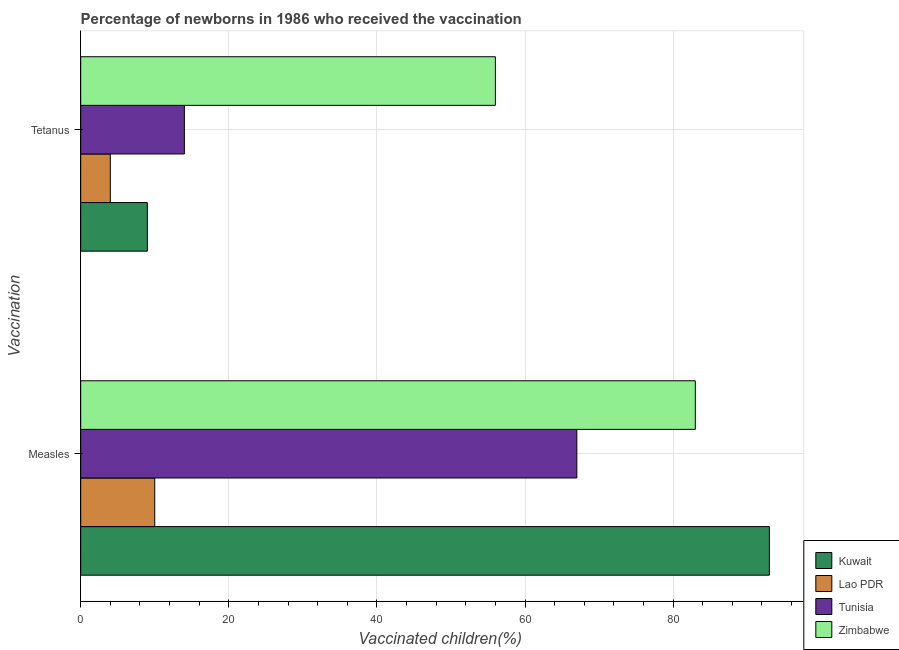How many different coloured bars are there?
Provide a succinct answer. 4. How many groups of bars are there?
Ensure brevity in your answer.  2. How many bars are there on the 2nd tick from the top?
Make the answer very short. 4. What is the label of the 2nd group of bars from the top?
Your answer should be compact. Measles. What is the percentage of newborns who received vaccination for measles in Kuwait?
Offer a terse response. 93. Across all countries, what is the maximum percentage of newborns who received vaccination for measles?
Give a very brief answer. 93. Across all countries, what is the minimum percentage of newborns who received vaccination for tetanus?
Make the answer very short. 4. In which country was the percentage of newborns who received vaccination for measles maximum?
Offer a terse response. Kuwait. In which country was the percentage of newborns who received vaccination for tetanus minimum?
Keep it short and to the point. Lao PDR. What is the total percentage of newborns who received vaccination for measles in the graph?
Provide a short and direct response. 253. What is the difference between the percentage of newborns who received vaccination for tetanus in Kuwait and that in Zimbabwe?
Your response must be concise. -47. What is the difference between the percentage of newborns who received vaccination for tetanus in Lao PDR and the percentage of newborns who received vaccination for measles in Tunisia?
Keep it short and to the point. -63. What is the average percentage of newborns who received vaccination for tetanus per country?
Offer a terse response. 20.75. What is the difference between the percentage of newborns who received vaccination for tetanus and percentage of newborns who received vaccination for measles in Kuwait?
Your answer should be very brief. -84. Is the percentage of newborns who received vaccination for measles in Zimbabwe less than that in Lao PDR?
Your answer should be compact. No. What does the 1st bar from the top in Tetanus represents?
Ensure brevity in your answer.  Zimbabwe. What does the 3rd bar from the bottom in Tetanus represents?
Provide a short and direct response. Tunisia. Are all the bars in the graph horizontal?
Provide a short and direct response. Yes. How many countries are there in the graph?
Make the answer very short. 4. What is the difference between two consecutive major ticks on the X-axis?
Give a very brief answer. 20. Are the values on the major ticks of X-axis written in scientific E-notation?
Ensure brevity in your answer.  No. Where does the legend appear in the graph?
Provide a short and direct response. Bottom right. How many legend labels are there?
Make the answer very short. 4. What is the title of the graph?
Your answer should be compact. Percentage of newborns in 1986 who received the vaccination. Does "South Africa" appear as one of the legend labels in the graph?
Provide a short and direct response. No. What is the label or title of the X-axis?
Keep it short and to the point. Vaccinated children(%)
. What is the label or title of the Y-axis?
Provide a short and direct response. Vaccination. What is the Vaccinated children(%)
 of Kuwait in Measles?
Make the answer very short. 93. What is the Vaccinated children(%)
 in Lao PDR in Measles?
Your answer should be compact. 10. What is the Vaccinated children(%)
 of Tunisia in Measles?
Your response must be concise. 67. What is the Vaccinated children(%)
 of Zimbabwe in Measles?
Ensure brevity in your answer.  83. What is the Vaccinated children(%)
 of Kuwait in Tetanus?
Offer a terse response. 9. What is the Vaccinated children(%)
 of Lao PDR in Tetanus?
Provide a short and direct response. 4. What is the Vaccinated children(%)
 of Tunisia in Tetanus?
Your answer should be compact. 14. Across all Vaccination, what is the maximum Vaccinated children(%)
 of Kuwait?
Your answer should be very brief. 93. Across all Vaccination, what is the maximum Vaccinated children(%)
 in Zimbabwe?
Offer a terse response. 83. Across all Vaccination, what is the minimum Vaccinated children(%)
 of Kuwait?
Offer a terse response. 9. Across all Vaccination, what is the minimum Vaccinated children(%)
 of Zimbabwe?
Make the answer very short. 56. What is the total Vaccinated children(%)
 in Kuwait in the graph?
Make the answer very short. 102. What is the total Vaccinated children(%)
 of Lao PDR in the graph?
Make the answer very short. 14. What is the total Vaccinated children(%)
 in Zimbabwe in the graph?
Provide a succinct answer. 139. What is the difference between the Vaccinated children(%)
 in Kuwait in Measles and that in Tetanus?
Your response must be concise. 84. What is the difference between the Vaccinated children(%)
 of Tunisia in Measles and that in Tetanus?
Ensure brevity in your answer.  53. What is the difference between the Vaccinated children(%)
 in Zimbabwe in Measles and that in Tetanus?
Your answer should be very brief. 27. What is the difference between the Vaccinated children(%)
 in Kuwait in Measles and the Vaccinated children(%)
 in Lao PDR in Tetanus?
Keep it short and to the point. 89. What is the difference between the Vaccinated children(%)
 of Kuwait in Measles and the Vaccinated children(%)
 of Tunisia in Tetanus?
Your answer should be very brief. 79. What is the difference between the Vaccinated children(%)
 in Kuwait in Measles and the Vaccinated children(%)
 in Zimbabwe in Tetanus?
Provide a succinct answer. 37. What is the difference between the Vaccinated children(%)
 in Lao PDR in Measles and the Vaccinated children(%)
 in Zimbabwe in Tetanus?
Offer a terse response. -46. What is the average Vaccinated children(%)
 in Tunisia per Vaccination?
Provide a short and direct response. 40.5. What is the average Vaccinated children(%)
 in Zimbabwe per Vaccination?
Make the answer very short. 69.5. What is the difference between the Vaccinated children(%)
 of Kuwait and Vaccinated children(%)
 of Tunisia in Measles?
Offer a very short reply. 26. What is the difference between the Vaccinated children(%)
 in Kuwait and Vaccinated children(%)
 in Zimbabwe in Measles?
Your response must be concise. 10. What is the difference between the Vaccinated children(%)
 of Lao PDR and Vaccinated children(%)
 of Tunisia in Measles?
Your answer should be compact. -57. What is the difference between the Vaccinated children(%)
 of Lao PDR and Vaccinated children(%)
 of Zimbabwe in Measles?
Make the answer very short. -73. What is the difference between the Vaccinated children(%)
 in Kuwait and Vaccinated children(%)
 in Lao PDR in Tetanus?
Give a very brief answer. 5. What is the difference between the Vaccinated children(%)
 in Kuwait and Vaccinated children(%)
 in Zimbabwe in Tetanus?
Provide a short and direct response. -47. What is the difference between the Vaccinated children(%)
 in Lao PDR and Vaccinated children(%)
 in Tunisia in Tetanus?
Give a very brief answer. -10. What is the difference between the Vaccinated children(%)
 of Lao PDR and Vaccinated children(%)
 of Zimbabwe in Tetanus?
Give a very brief answer. -52. What is the difference between the Vaccinated children(%)
 of Tunisia and Vaccinated children(%)
 of Zimbabwe in Tetanus?
Give a very brief answer. -42. What is the ratio of the Vaccinated children(%)
 in Kuwait in Measles to that in Tetanus?
Keep it short and to the point. 10.33. What is the ratio of the Vaccinated children(%)
 in Lao PDR in Measles to that in Tetanus?
Keep it short and to the point. 2.5. What is the ratio of the Vaccinated children(%)
 of Tunisia in Measles to that in Tetanus?
Offer a very short reply. 4.79. What is the ratio of the Vaccinated children(%)
 of Zimbabwe in Measles to that in Tetanus?
Offer a very short reply. 1.48. What is the difference between the highest and the second highest Vaccinated children(%)
 in Kuwait?
Provide a succinct answer. 84. What is the difference between the highest and the second highest Vaccinated children(%)
 of Tunisia?
Provide a short and direct response. 53. What is the difference between the highest and the second highest Vaccinated children(%)
 of Zimbabwe?
Make the answer very short. 27. What is the difference between the highest and the lowest Vaccinated children(%)
 of Kuwait?
Keep it short and to the point. 84. What is the difference between the highest and the lowest Vaccinated children(%)
 in Tunisia?
Your response must be concise. 53. 